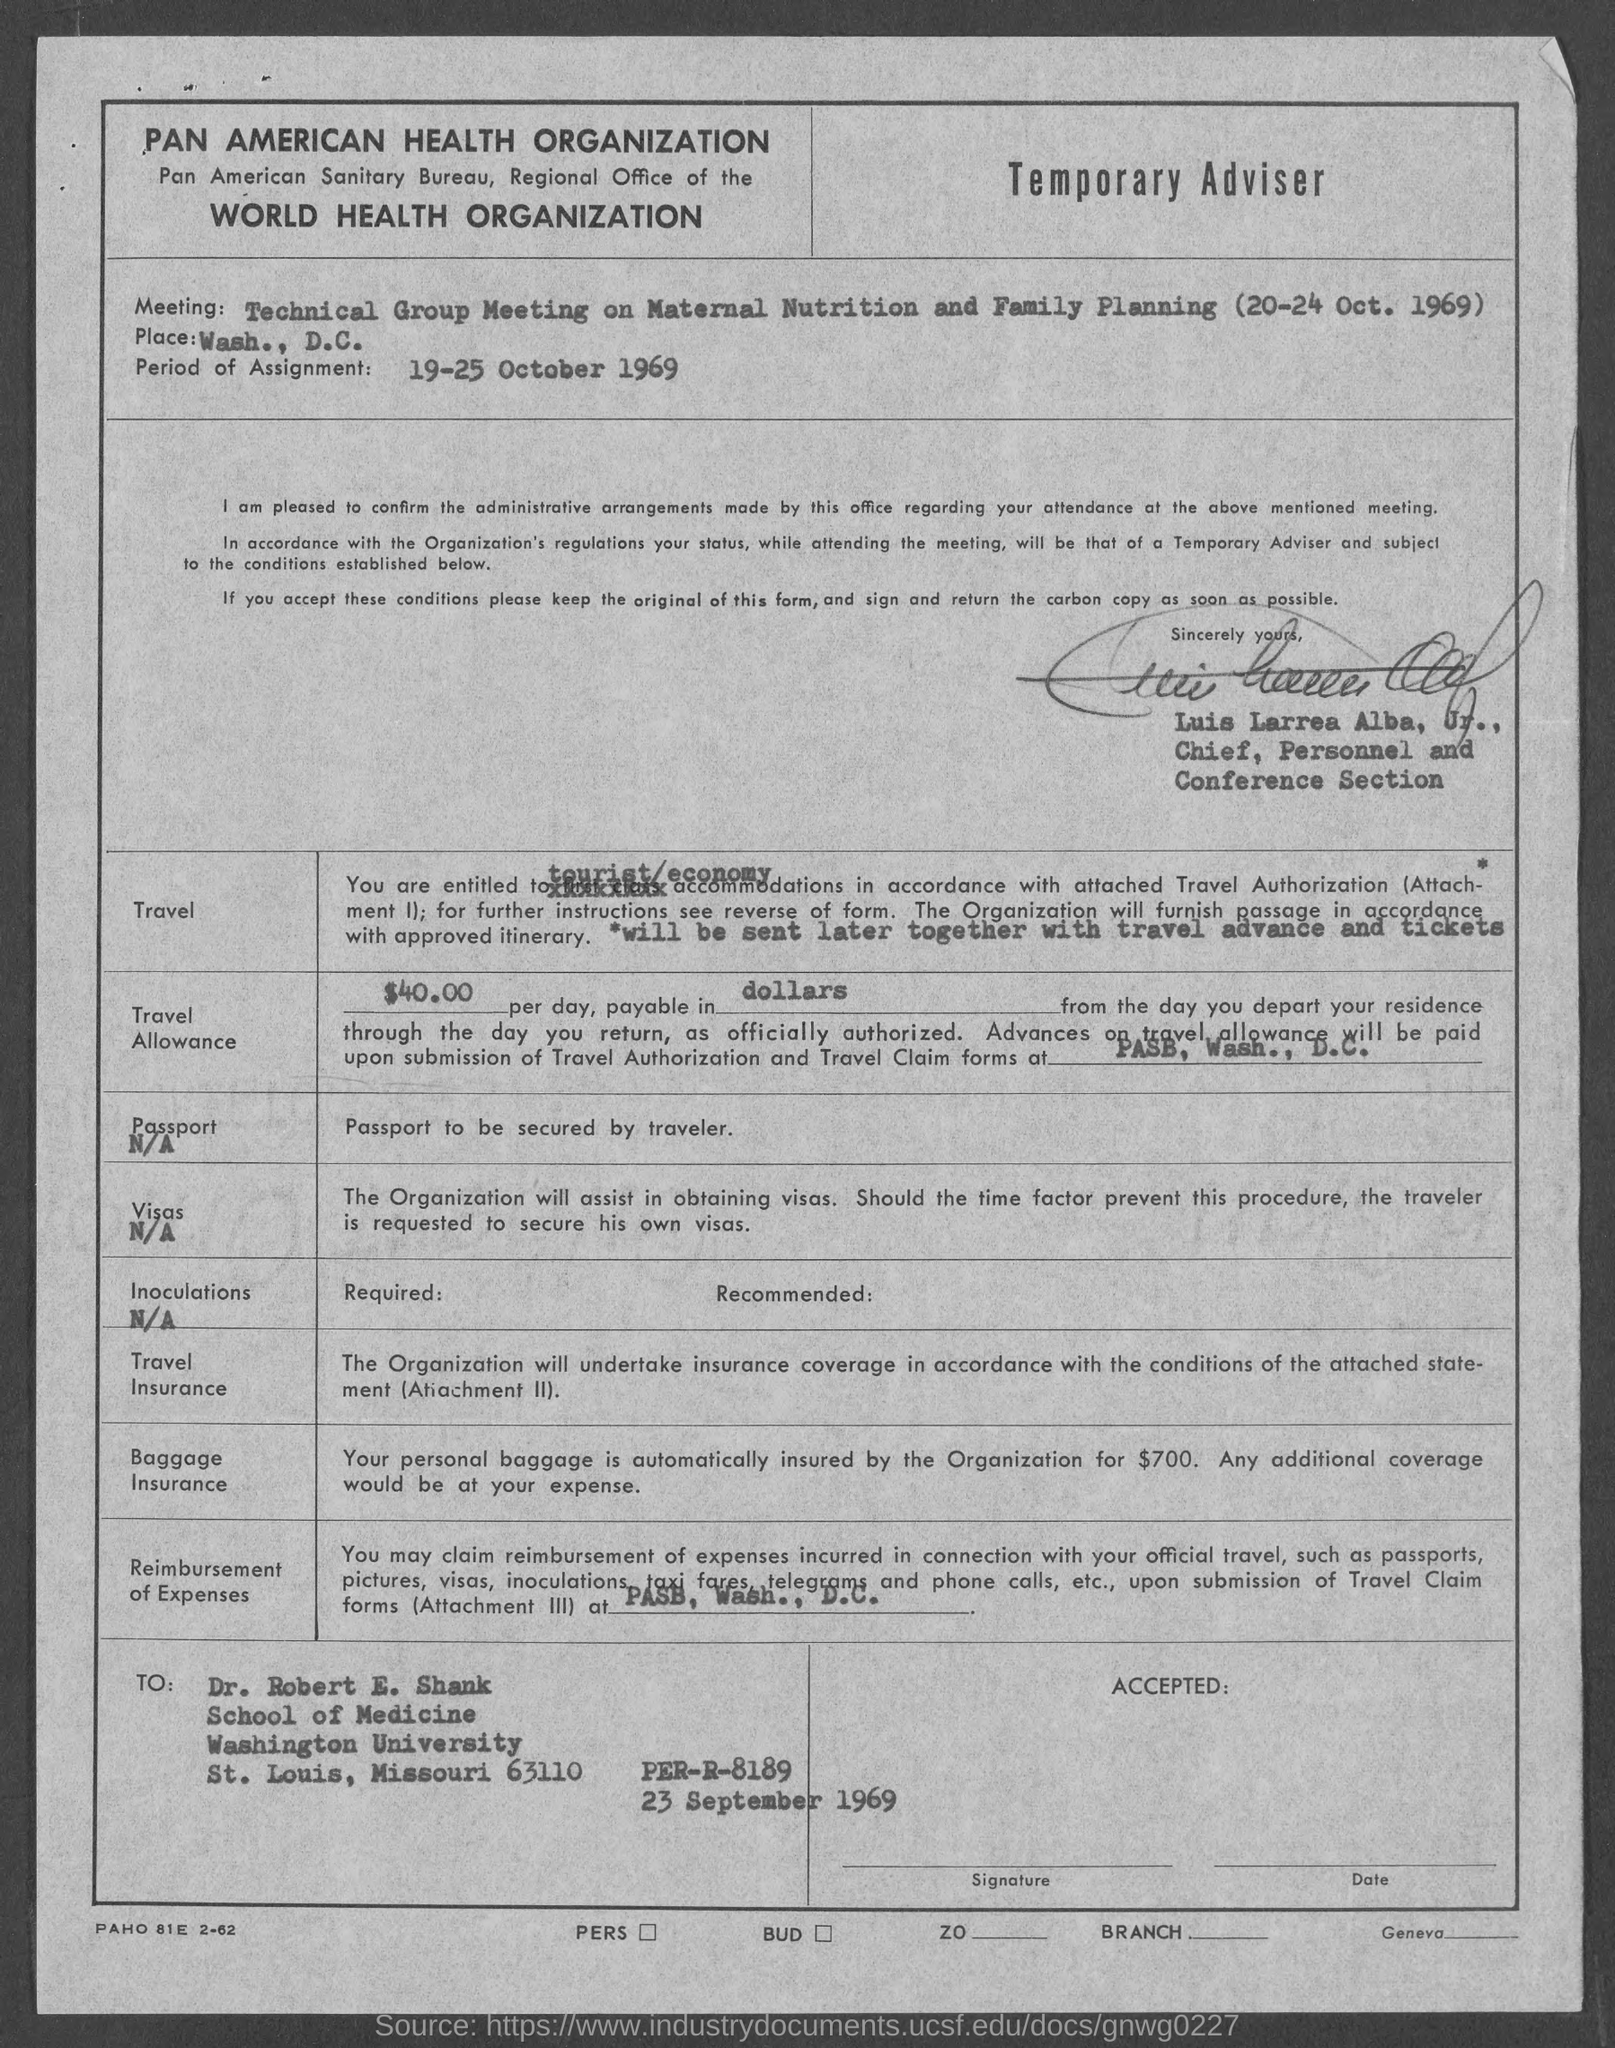What is the period of assignment?
Provide a succinct answer. 19-25 October 1969. Who has signed the form?
Provide a succinct answer. Luis Larrea Alba, Jr. How much is the Travel Allowance per day, payable in dollars?
Make the answer very short. 40.00. What is the meeting about?
Offer a very short reply. Technical Group Meeting on Maternal Nutrition and Family Planning. When is the meeting to be held?
Offer a terse response. 20-24 Oct. 1969. 